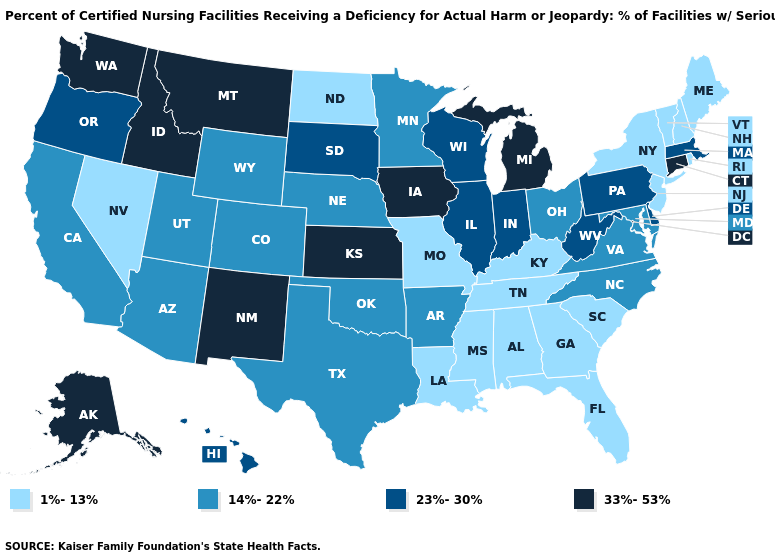What is the highest value in the South ?
Answer briefly. 23%-30%. What is the lowest value in the USA?
Be succinct. 1%-13%. What is the lowest value in the Northeast?
Write a very short answer. 1%-13%. What is the value of New Jersey?
Answer briefly. 1%-13%. Which states have the lowest value in the USA?
Give a very brief answer. Alabama, Florida, Georgia, Kentucky, Louisiana, Maine, Mississippi, Missouri, Nevada, New Hampshire, New Jersey, New York, North Dakota, Rhode Island, South Carolina, Tennessee, Vermont. What is the lowest value in the South?
Be succinct. 1%-13%. What is the highest value in states that border California?
Write a very short answer. 23%-30%. Does New York have the lowest value in the USA?
Concise answer only. Yes. Does Arizona have a higher value than Ohio?
Quick response, please. No. What is the lowest value in the USA?
Concise answer only. 1%-13%. What is the lowest value in the West?
Give a very brief answer. 1%-13%. Name the states that have a value in the range 23%-30%?
Concise answer only. Delaware, Hawaii, Illinois, Indiana, Massachusetts, Oregon, Pennsylvania, South Dakota, West Virginia, Wisconsin. Name the states that have a value in the range 14%-22%?
Short answer required. Arizona, Arkansas, California, Colorado, Maryland, Minnesota, Nebraska, North Carolina, Ohio, Oklahoma, Texas, Utah, Virginia, Wyoming. What is the value of Kentucky?
Short answer required. 1%-13%. 